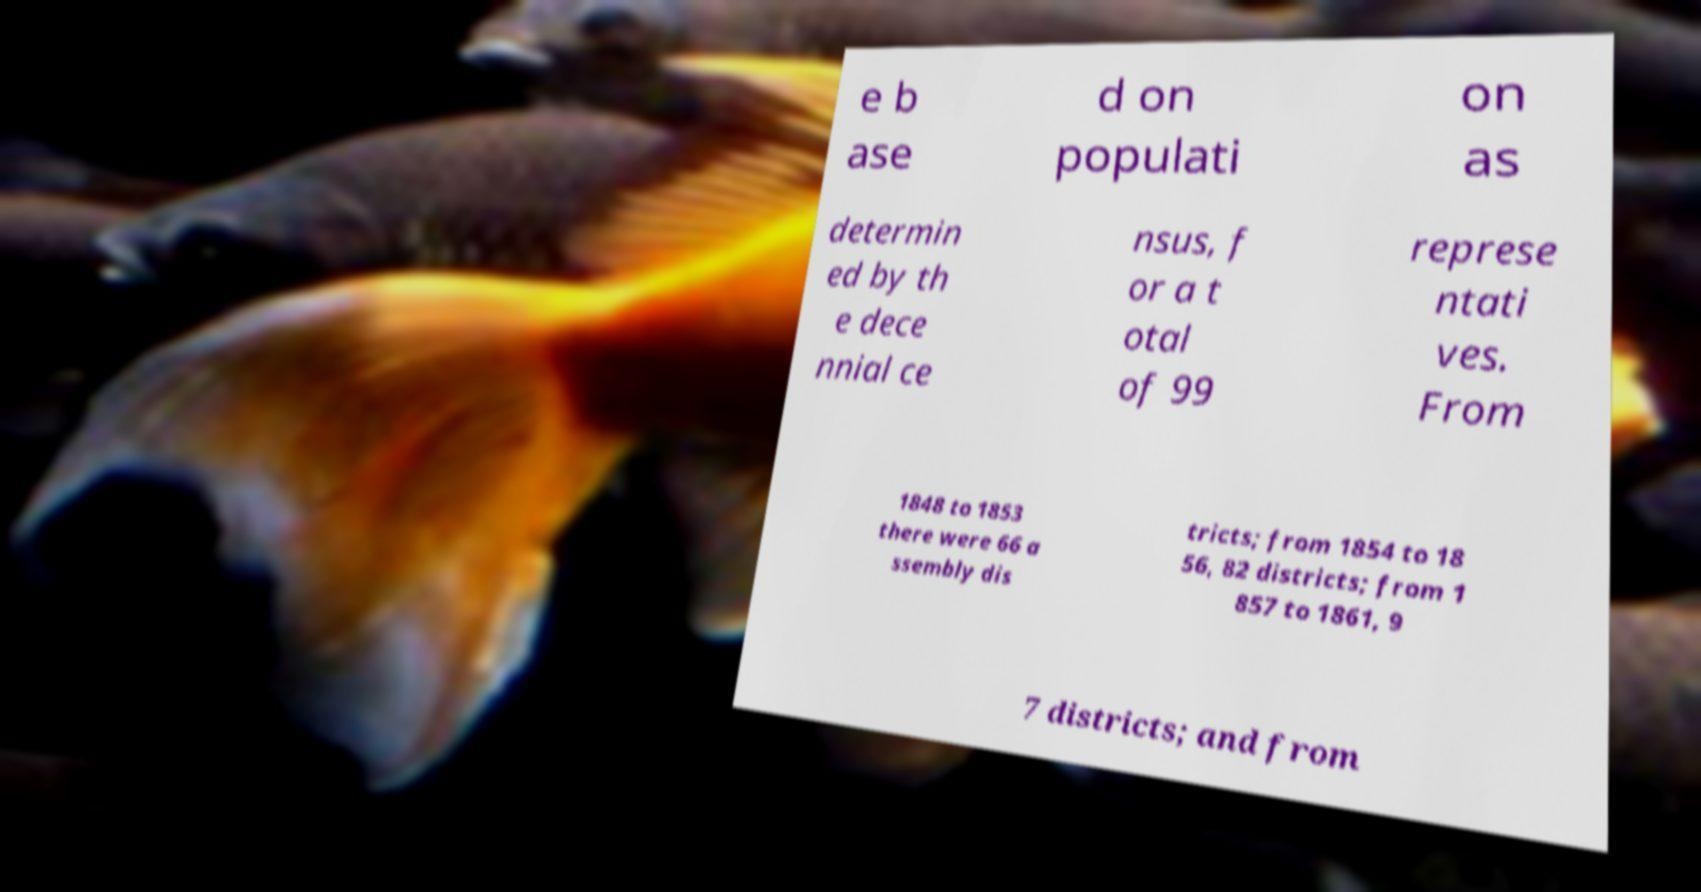Could you assist in decoding the text presented in this image and type it out clearly? e b ase d on populati on as determin ed by th e dece nnial ce nsus, f or a t otal of 99 represe ntati ves. From 1848 to 1853 there were 66 a ssembly dis tricts; from 1854 to 18 56, 82 districts; from 1 857 to 1861, 9 7 districts; and from 